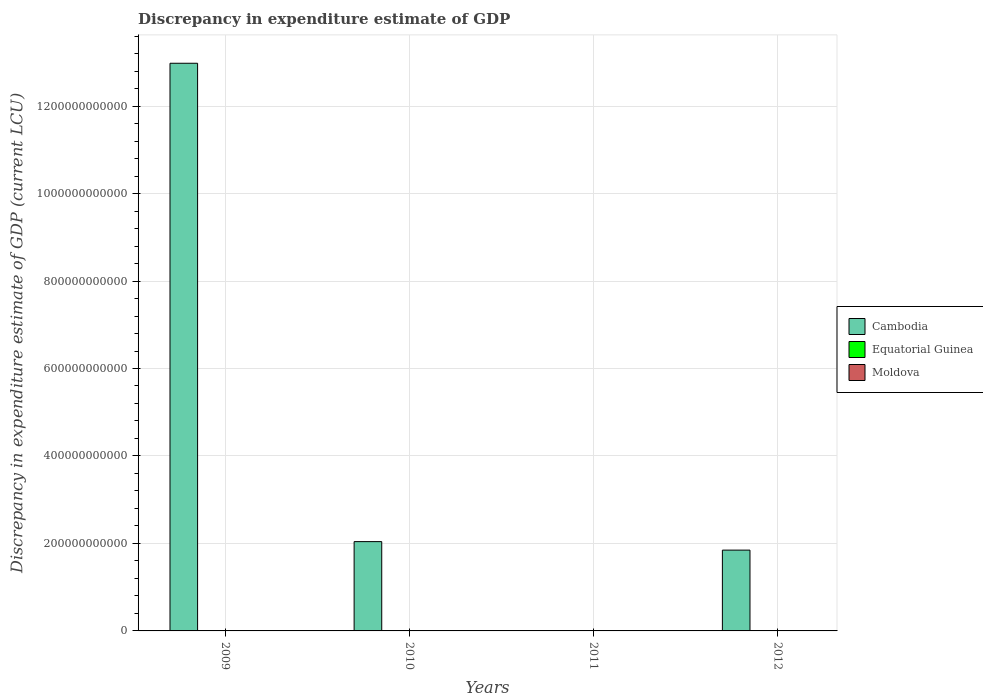How many different coloured bars are there?
Your response must be concise. 3. Are the number of bars on each tick of the X-axis equal?
Give a very brief answer. No. How many bars are there on the 1st tick from the left?
Provide a short and direct response. 3. How many bars are there on the 4th tick from the right?
Your response must be concise. 3. What is the label of the 4th group of bars from the left?
Offer a terse response. 2012. In how many cases, is the number of bars for a given year not equal to the number of legend labels?
Provide a short and direct response. 3. What is the discrepancy in expenditure estimate of GDP in Equatorial Guinea in 2010?
Your answer should be compact. 0. Across all years, what is the maximum discrepancy in expenditure estimate of GDP in Cambodia?
Provide a succinct answer. 1.30e+12. Across all years, what is the minimum discrepancy in expenditure estimate of GDP in Cambodia?
Offer a terse response. 0. What is the total discrepancy in expenditure estimate of GDP in Equatorial Guinea in the graph?
Ensure brevity in your answer.  0. What is the difference between the discrepancy in expenditure estimate of GDP in Cambodia in 2009 and that in 2012?
Offer a very short reply. 1.11e+12. What is the difference between the discrepancy in expenditure estimate of GDP in Cambodia in 2011 and the discrepancy in expenditure estimate of GDP in Equatorial Guinea in 2012?
Ensure brevity in your answer.  0. What is the average discrepancy in expenditure estimate of GDP in Moldova per year?
Provide a short and direct response. 2.25e+05. In the year 2009, what is the difference between the discrepancy in expenditure estimate of GDP in Equatorial Guinea and discrepancy in expenditure estimate of GDP in Moldova?
Make the answer very short. 0. In how many years, is the discrepancy in expenditure estimate of GDP in Moldova greater than 160000000000 LCU?
Give a very brief answer. 0. What is the ratio of the discrepancy in expenditure estimate of GDP in Cambodia in 2009 to that in 2012?
Your answer should be compact. 7.03. What is the difference between the highest and the second highest discrepancy in expenditure estimate of GDP in Moldova?
Your response must be concise. 3.31e+05. What is the difference between the highest and the lowest discrepancy in expenditure estimate of GDP in Equatorial Guinea?
Make the answer very short. 0. In how many years, is the discrepancy in expenditure estimate of GDP in Moldova greater than the average discrepancy in expenditure estimate of GDP in Moldova taken over all years?
Provide a short and direct response. 2. How many bars are there?
Provide a succinct answer. 7. What is the difference between two consecutive major ticks on the Y-axis?
Ensure brevity in your answer.  2.00e+11. Does the graph contain any zero values?
Your answer should be very brief. Yes. Does the graph contain grids?
Ensure brevity in your answer.  Yes. Where does the legend appear in the graph?
Provide a succinct answer. Center right. How are the legend labels stacked?
Make the answer very short. Vertical. What is the title of the graph?
Provide a succinct answer. Discrepancy in expenditure estimate of GDP. Does "Nepal" appear as one of the legend labels in the graph?
Your answer should be compact. No. What is the label or title of the Y-axis?
Your response must be concise. Discrepancy in expenditure estimate of GDP (current LCU). What is the Discrepancy in expenditure estimate of GDP (current LCU) in Cambodia in 2009?
Offer a very short reply. 1.30e+12. What is the Discrepancy in expenditure estimate of GDP (current LCU) in Equatorial Guinea in 2009?
Your answer should be very brief. 0. What is the Discrepancy in expenditure estimate of GDP (current LCU) of Moldova in 2009?
Your answer should be very brief. 4e-6. What is the Discrepancy in expenditure estimate of GDP (current LCU) in Cambodia in 2010?
Provide a short and direct response. 2.04e+11. What is the Discrepancy in expenditure estimate of GDP (current LCU) of Moldova in 2010?
Your answer should be compact. 0. What is the Discrepancy in expenditure estimate of GDP (current LCU) in Cambodia in 2011?
Ensure brevity in your answer.  0. What is the Discrepancy in expenditure estimate of GDP (current LCU) of Moldova in 2011?
Give a very brief answer. 6.15e+05. What is the Discrepancy in expenditure estimate of GDP (current LCU) of Cambodia in 2012?
Your response must be concise. 1.85e+11. What is the Discrepancy in expenditure estimate of GDP (current LCU) of Moldova in 2012?
Your response must be concise. 2.84e+05. Across all years, what is the maximum Discrepancy in expenditure estimate of GDP (current LCU) of Cambodia?
Your answer should be very brief. 1.30e+12. Across all years, what is the maximum Discrepancy in expenditure estimate of GDP (current LCU) in Equatorial Guinea?
Your response must be concise. 0. Across all years, what is the maximum Discrepancy in expenditure estimate of GDP (current LCU) of Moldova?
Offer a terse response. 6.15e+05. What is the total Discrepancy in expenditure estimate of GDP (current LCU) of Cambodia in the graph?
Provide a short and direct response. 1.69e+12. What is the total Discrepancy in expenditure estimate of GDP (current LCU) of Moldova in the graph?
Keep it short and to the point. 8.99e+05. What is the difference between the Discrepancy in expenditure estimate of GDP (current LCU) in Cambodia in 2009 and that in 2010?
Give a very brief answer. 1.09e+12. What is the difference between the Discrepancy in expenditure estimate of GDP (current LCU) in Moldova in 2009 and that in 2011?
Offer a very short reply. -6.15e+05. What is the difference between the Discrepancy in expenditure estimate of GDP (current LCU) of Cambodia in 2009 and that in 2012?
Give a very brief answer. 1.11e+12. What is the difference between the Discrepancy in expenditure estimate of GDP (current LCU) in Moldova in 2009 and that in 2012?
Your response must be concise. -2.84e+05. What is the difference between the Discrepancy in expenditure estimate of GDP (current LCU) of Cambodia in 2010 and that in 2012?
Your response must be concise. 1.94e+1. What is the difference between the Discrepancy in expenditure estimate of GDP (current LCU) in Moldova in 2011 and that in 2012?
Provide a succinct answer. 3.31e+05. What is the difference between the Discrepancy in expenditure estimate of GDP (current LCU) of Cambodia in 2009 and the Discrepancy in expenditure estimate of GDP (current LCU) of Moldova in 2011?
Your answer should be very brief. 1.30e+12. What is the difference between the Discrepancy in expenditure estimate of GDP (current LCU) in Equatorial Guinea in 2009 and the Discrepancy in expenditure estimate of GDP (current LCU) in Moldova in 2011?
Offer a terse response. -6.15e+05. What is the difference between the Discrepancy in expenditure estimate of GDP (current LCU) in Cambodia in 2009 and the Discrepancy in expenditure estimate of GDP (current LCU) in Moldova in 2012?
Ensure brevity in your answer.  1.30e+12. What is the difference between the Discrepancy in expenditure estimate of GDP (current LCU) in Equatorial Guinea in 2009 and the Discrepancy in expenditure estimate of GDP (current LCU) in Moldova in 2012?
Offer a very short reply. -2.84e+05. What is the difference between the Discrepancy in expenditure estimate of GDP (current LCU) in Cambodia in 2010 and the Discrepancy in expenditure estimate of GDP (current LCU) in Moldova in 2011?
Your response must be concise. 2.04e+11. What is the difference between the Discrepancy in expenditure estimate of GDP (current LCU) in Cambodia in 2010 and the Discrepancy in expenditure estimate of GDP (current LCU) in Moldova in 2012?
Your answer should be very brief. 2.04e+11. What is the average Discrepancy in expenditure estimate of GDP (current LCU) of Cambodia per year?
Your answer should be compact. 4.22e+11. What is the average Discrepancy in expenditure estimate of GDP (current LCU) in Moldova per year?
Ensure brevity in your answer.  2.25e+05. In the year 2009, what is the difference between the Discrepancy in expenditure estimate of GDP (current LCU) of Cambodia and Discrepancy in expenditure estimate of GDP (current LCU) of Equatorial Guinea?
Offer a terse response. 1.30e+12. In the year 2009, what is the difference between the Discrepancy in expenditure estimate of GDP (current LCU) of Cambodia and Discrepancy in expenditure estimate of GDP (current LCU) of Moldova?
Give a very brief answer. 1.30e+12. In the year 2009, what is the difference between the Discrepancy in expenditure estimate of GDP (current LCU) in Equatorial Guinea and Discrepancy in expenditure estimate of GDP (current LCU) in Moldova?
Your answer should be very brief. 0. In the year 2012, what is the difference between the Discrepancy in expenditure estimate of GDP (current LCU) of Cambodia and Discrepancy in expenditure estimate of GDP (current LCU) of Moldova?
Offer a very short reply. 1.85e+11. What is the ratio of the Discrepancy in expenditure estimate of GDP (current LCU) in Cambodia in 2009 to that in 2010?
Your answer should be very brief. 6.36. What is the ratio of the Discrepancy in expenditure estimate of GDP (current LCU) of Moldova in 2009 to that in 2011?
Keep it short and to the point. 0. What is the ratio of the Discrepancy in expenditure estimate of GDP (current LCU) of Cambodia in 2009 to that in 2012?
Make the answer very short. 7.03. What is the ratio of the Discrepancy in expenditure estimate of GDP (current LCU) in Cambodia in 2010 to that in 2012?
Keep it short and to the point. 1.11. What is the ratio of the Discrepancy in expenditure estimate of GDP (current LCU) in Moldova in 2011 to that in 2012?
Your response must be concise. 2.17. What is the difference between the highest and the second highest Discrepancy in expenditure estimate of GDP (current LCU) of Cambodia?
Give a very brief answer. 1.09e+12. What is the difference between the highest and the second highest Discrepancy in expenditure estimate of GDP (current LCU) in Moldova?
Offer a terse response. 3.31e+05. What is the difference between the highest and the lowest Discrepancy in expenditure estimate of GDP (current LCU) in Cambodia?
Provide a succinct answer. 1.30e+12. What is the difference between the highest and the lowest Discrepancy in expenditure estimate of GDP (current LCU) of Equatorial Guinea?
Provide a short and direct response. 0. What is the difference between the highest and the lowest Discrepancy in expenditure estimate of GDP (current LCU) of Moldova?
Give a very brief answer. 6.15e+05. 